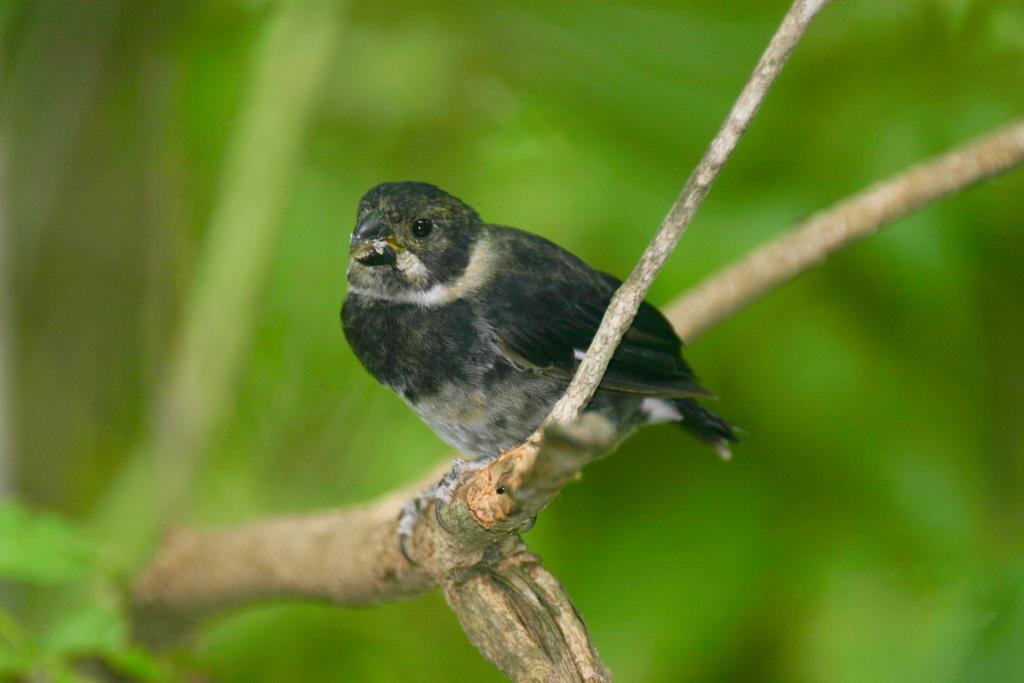Can you describe this image briefly? In this image I can see the bird on the branch. The bird is in black and white color and the background is in green color. 